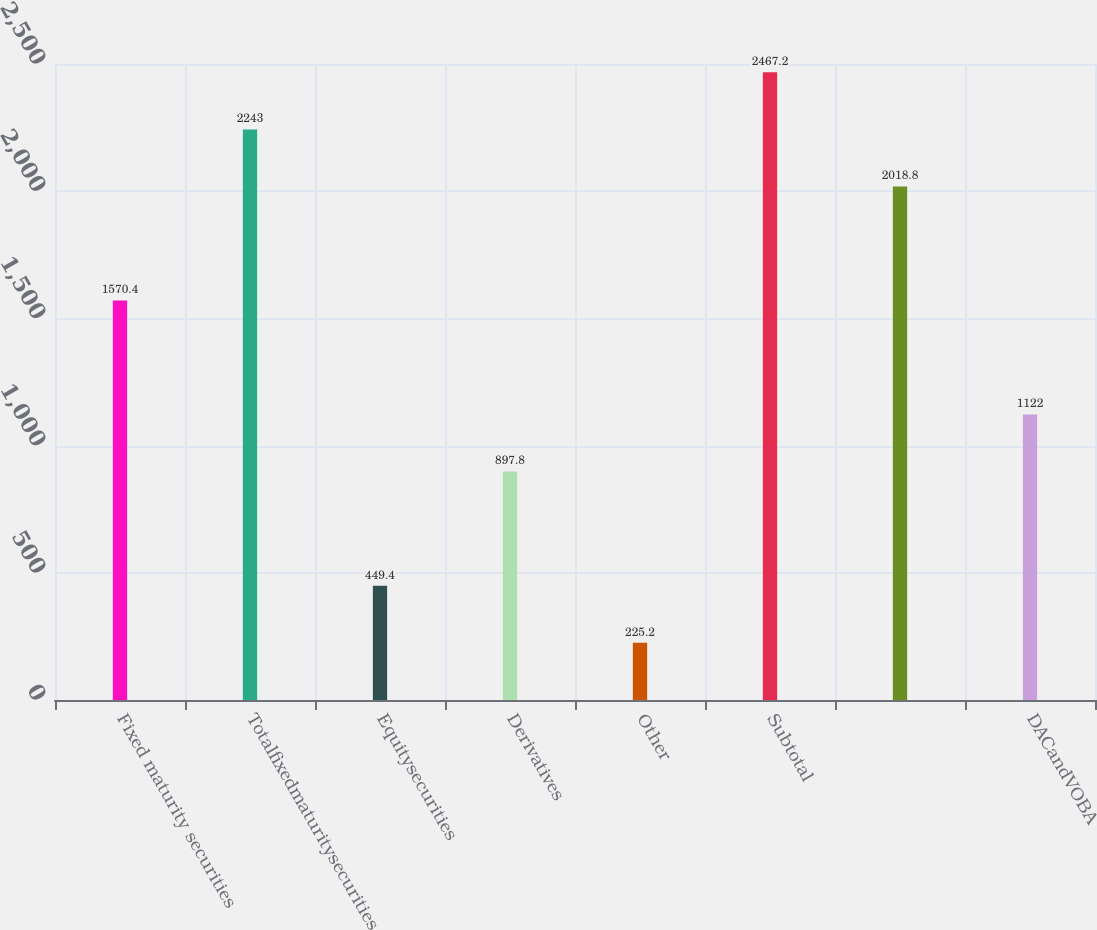Convert chart to OTSL. <chart><loc_0><loc_0><loc_500><loc_500><bar_chart><fcel>Fixed maturity securities<fcel>Totalfixedmaturitysecurities<fcel>Equitysecurities<fcel>Derivatives<fcel>Other<fcel>Subtotal<fcel>Unnamed: 6<fcel>DACandVOBA<nl><fcel>1570.4<fcel>2243<fcel>449.4<fcel>897.8<fcel>225.2<fcel>2467.2<fcel>2018.8<fcel>1122<nl></chart> 